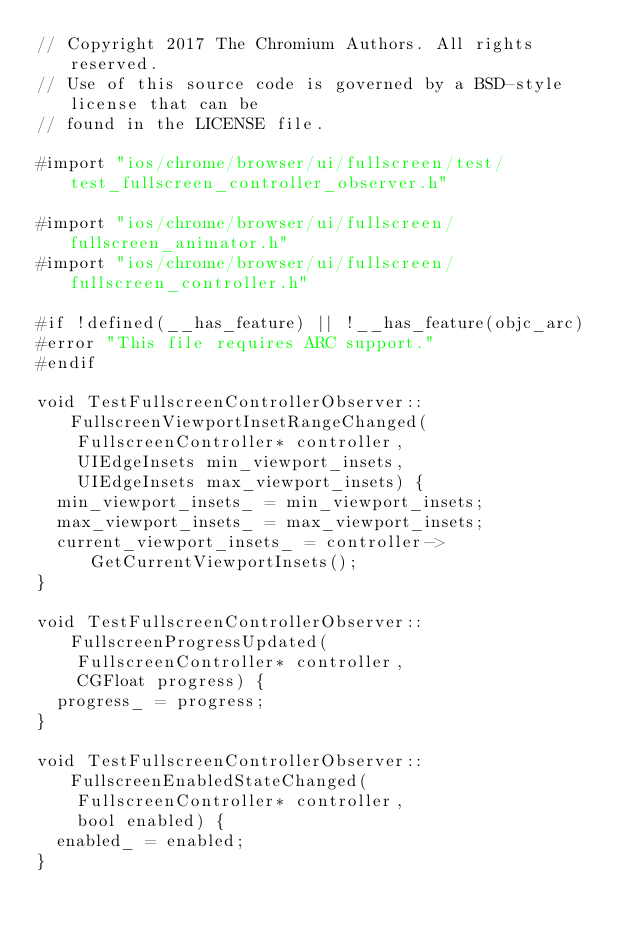Convert code to text. <code><loc_0><loc_0><loc_500><loc_500><_ObjectiveC_>// Copyright 2017 The Chromium Authors. All rights reserved.
// Use of this source code is governed by a BSD-style license that can be
// found in the LICENSE file.

#import "ios/chrome/browser/ui/fullscreen/test/test_fullscreen_controller_observer.h"

#import "ios/chrome/browser/ui/fullscreen/fullscreen_animator.h"
#import "ios/chrome/browser/ui/fullscreen/fullscreen_controller.h"

#if !defined(__has_feature) || !__has_feature(objc_arc)
#error "This file requires ARC support."
#endif

void TestFullscreenControllerObserver::FullscreenViewportInsetRangeChanged(
    FullscreenController* controller,
    UIEdgeInsets min_viewport_insets,
    UIEdgeInsets max_viewport_insets) {
  min_viewport_insets_ = min_viewport_insets;
  max_viewport_insets_ = max_viewport_insets;
  current_viewport_insets_ = controller->GetCurrentViewportInsets();
}

void TestFullscreenControllerObserver::FullscreenProgressUpdated(
    FullscreenController* controller,
    CGFloat progress) {
  progress_ = progress;
}

void TestFullscreenControllerObserver::FullscreenEnabledStateChanged(
    FullscreenController* controller,
    bool enabled) {
  enabled_ = enabled;
}
</code> 